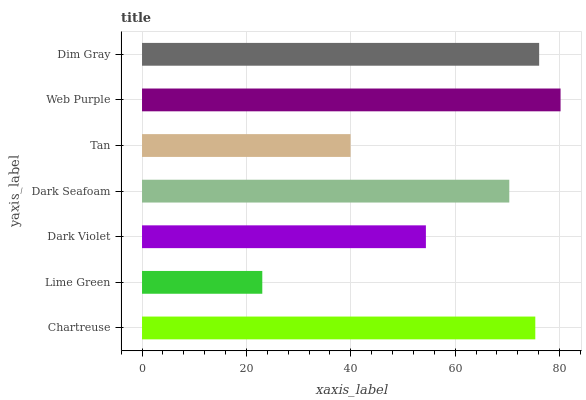Is Lime Green the minimum?
Answer yes or no. Yes. Is Web Purple the maximum?
Answer yes or no. Yes. Is Dark Violet the minimum?
Answer yes or no. No. Is Dark Violet the maximum?
Answer yes or no. No. Is Dark Violet greater than Lime Green?
Answer yes or no. Yes. Is Lime Green less than Dark Violet?
Answer yes or no. Yes. Is Lime Green greater than Dark Violet?
Answer yes or no. No. Is Dark Violet less than Lime Green?
Answer yes or no. No. Is Dark Seafoam the high median?
Answer yes or no. Yes. Is Dark Seafoam the low median?
Answer yes or no. Yes. Is Dim Gray the high median?
Answer yes or no. No. Is Lime Green the low median?
Answer yes or no. No. 